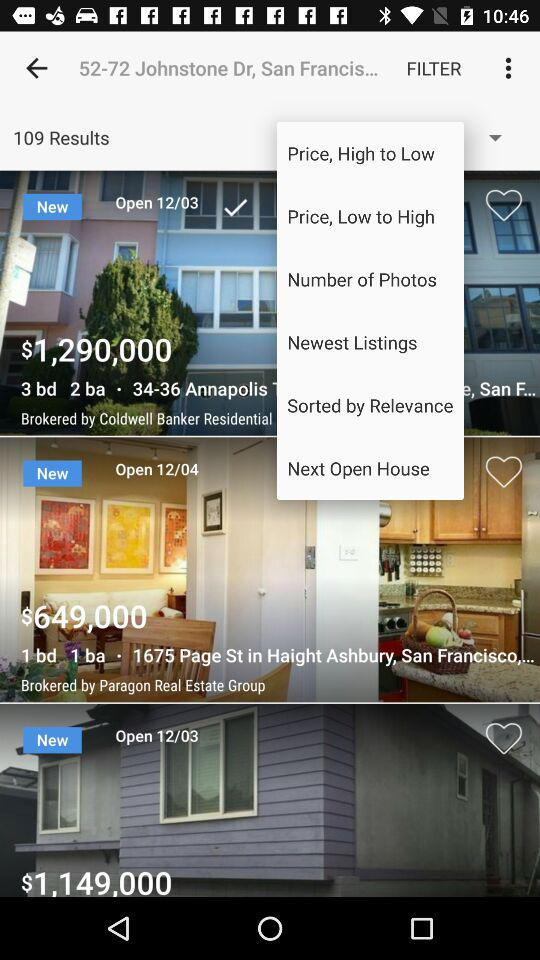Who is the broker of the property that is selected? The broker is "Coldwell Banker Residential". 